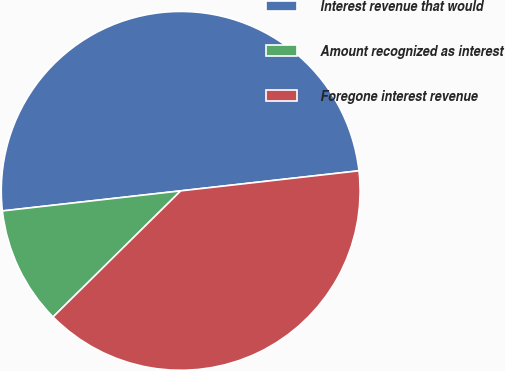Convert chart. <chart><loc_0><loc_0><loc_500><loc_500><pie_chart><fcel>Interest revenue that would<fcel>Amount recognized as interest<fcel>Foregone interest revenue<nl><fcel>50.0%<fcel>10.62%<fcel>39.38%<nl></chart> 